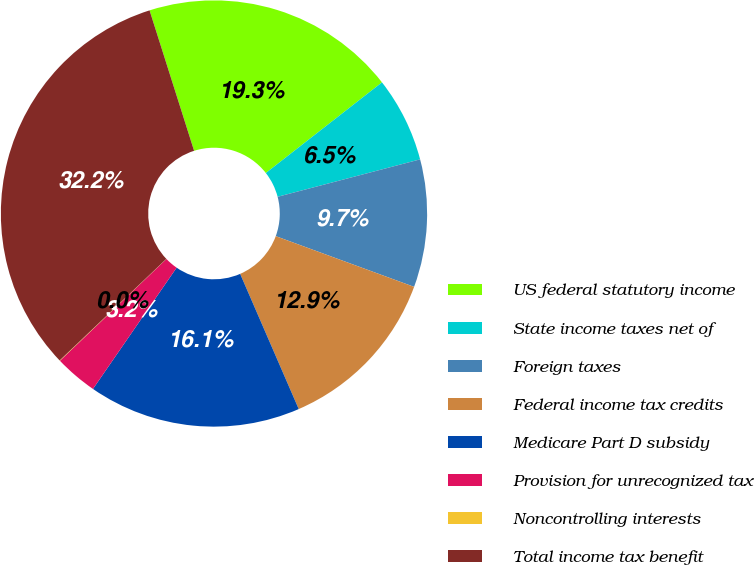Convert chart to OTSL. <chart><loc_0><loc_0><loc_500><loc_500><pie_chart><fcel>US federal statutory income<fcel>State income taxes net of<fcel>Foreign taxes<fcel>Federal income tax credits<fcel>Medicare Part D subsidy<fcel>Provision for unrecognized tax<fcel>Noncontrolling interests<fcel>Total income tax benefit<nl><fcel>19.34%<fcel>6.46%<fcel>9.68%<fcel>12.9%<fcel>16.12%<fcel>3.25%<fcel>0.03%<fcel>32.22%<nl></chart> 